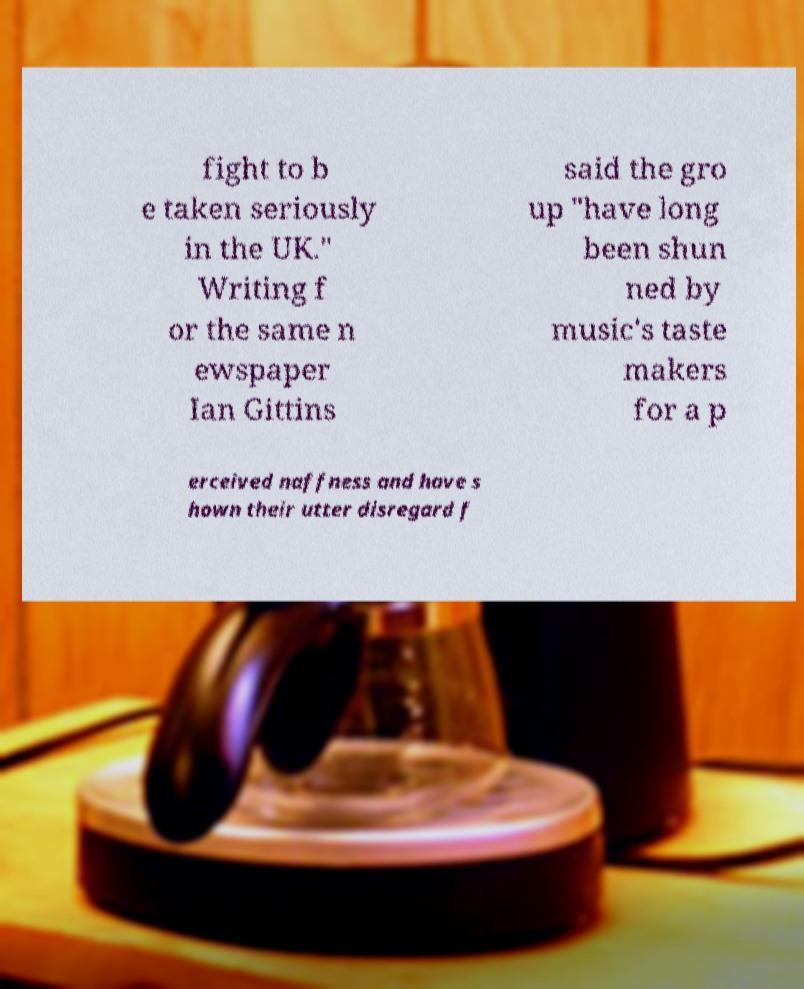What messages or text are displayed in this image? I need them in a readable, typed format. fight to b e taken seriously in the UK." Writing f or the same n ewspaper Ian Gittins said the gro up "have long been shun ned by music's taste makers for a p erceived naffness and have s hown their utter disregard f 